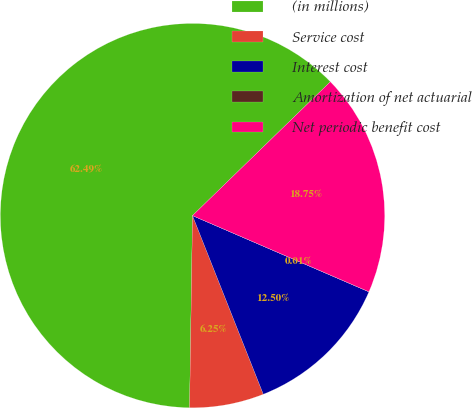Convert chart. <chart><loc_0><loc_0><loc_500><loc_500><pie_chart><fcel>(in millions)<fcel>Service cost<fcel>Interest cost<fcel>Amortization of net actuarial<fcel>Net periodic benefit cost<nl><fcel>62.49%<fcel>6.25%<fcel>12.5%<fcel>0.01%<fcel>18.75%<nl></chart> 